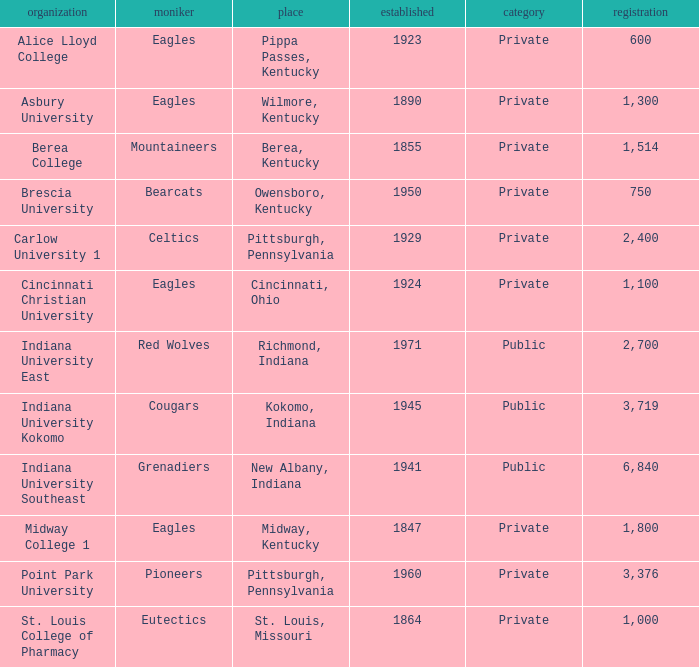Which of the private colleges is the oldest, and whose nickname is the Mountaineers? 1855.0. 